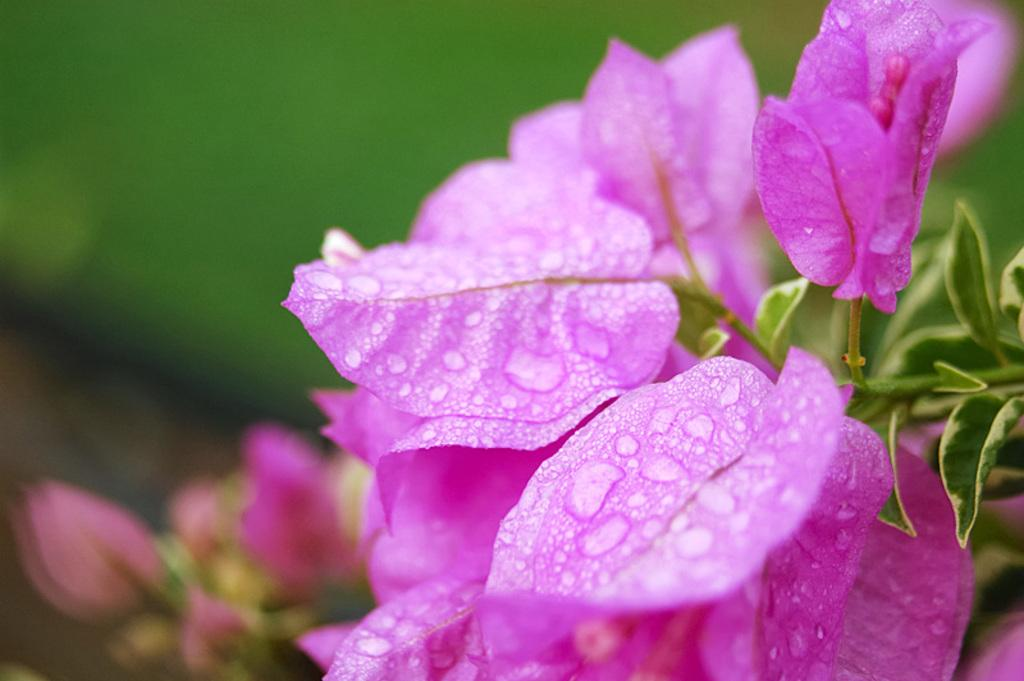What type of plants can be seen in the image? There are flowers in the image. What color are the flowers? The flowers are pink in color. What can be observed on the surface of the flowers? There are water droplets on the flowers. What other part of the plant is visible in the image? There are green leaves in the image. How would you describe the background of the image? The background of the image is blurred. What type of vegetable is being used to join the flowers together in the image? There is no vegetable present in the image, and the flowers are not being joined together. 